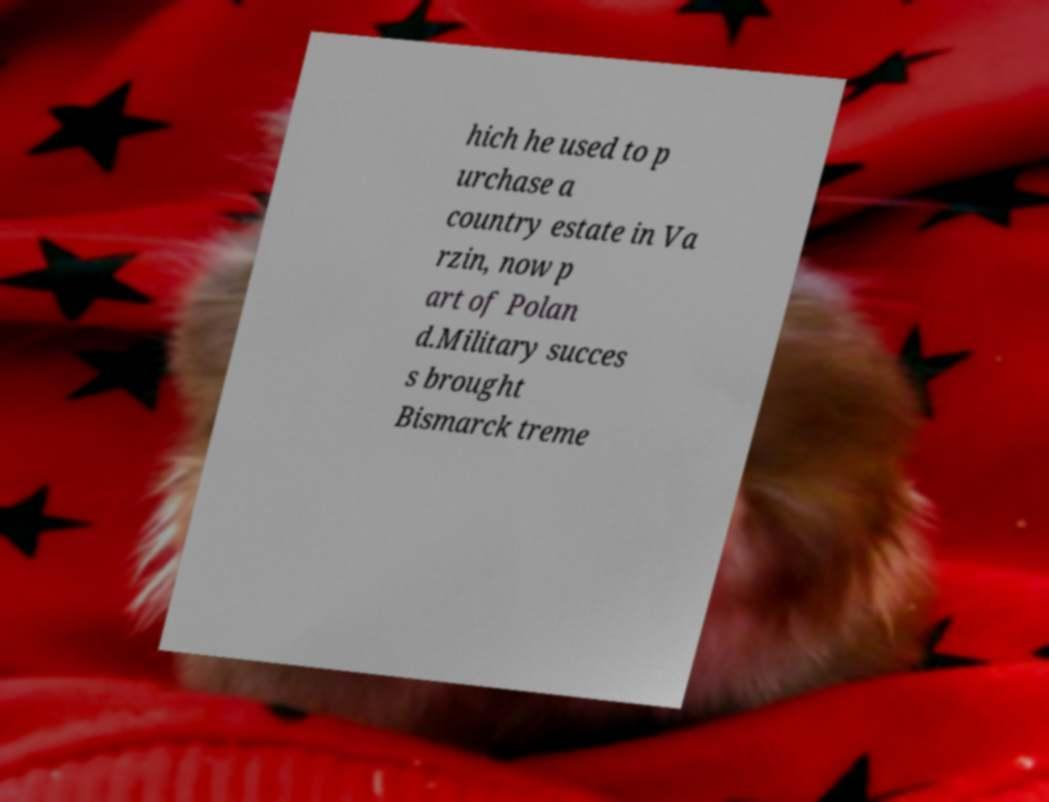What messages or text are displayed in this image? I need them in a readable, typed format. hich he used to p urchase a country estate in Va rzin, now p art of Polan d.Military succes s brought Bismarck treme 